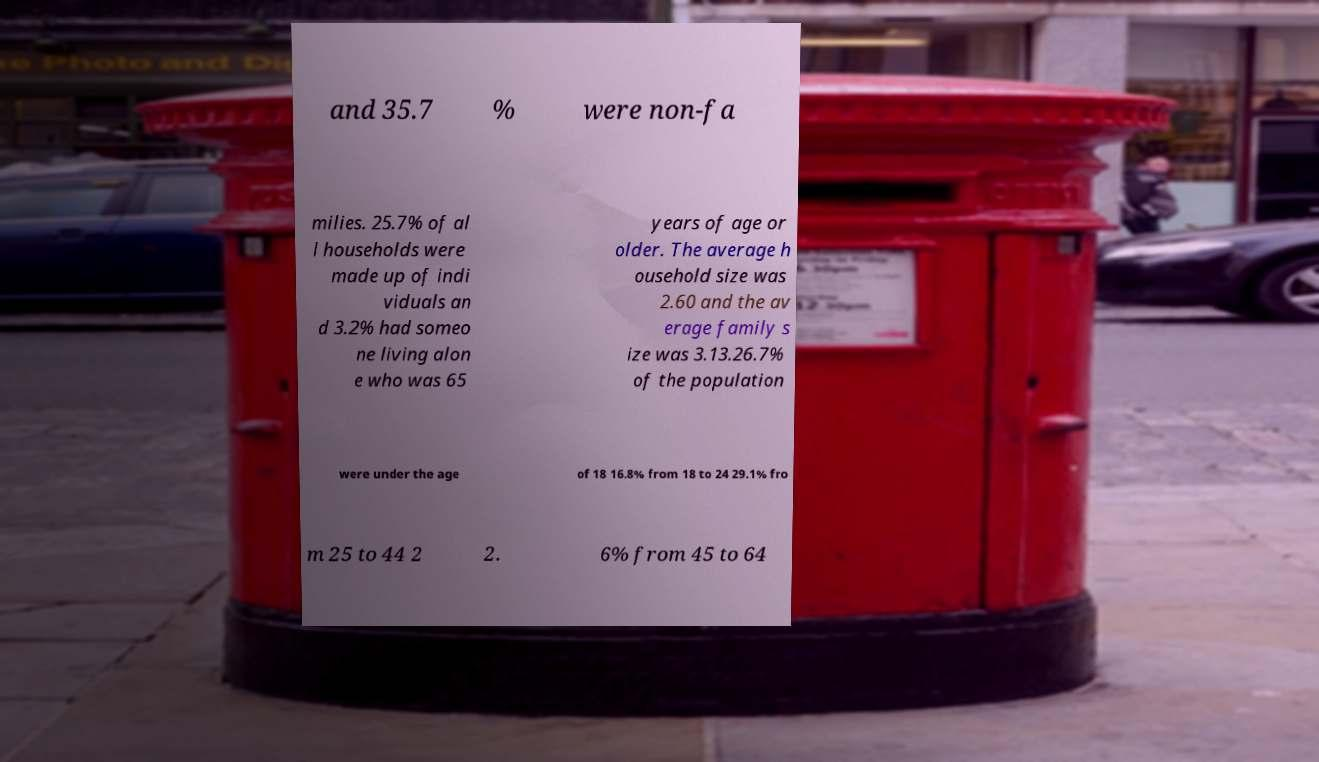Please identify and transcribe the text found in this image. and 35.7 % were non-fa milies. 25.7% of al l households were made up of indi viduals an d 3.2% had someo ne living alon e who was 65 years of age or older. The average h ousehold size was 2.60 and the av erage family s ize was 3.13.26.7% of the population were under the age of 18 16.8% from 18 to 24 29.1% fro m 25 to 44 2 2. 6% from 45 to 64 